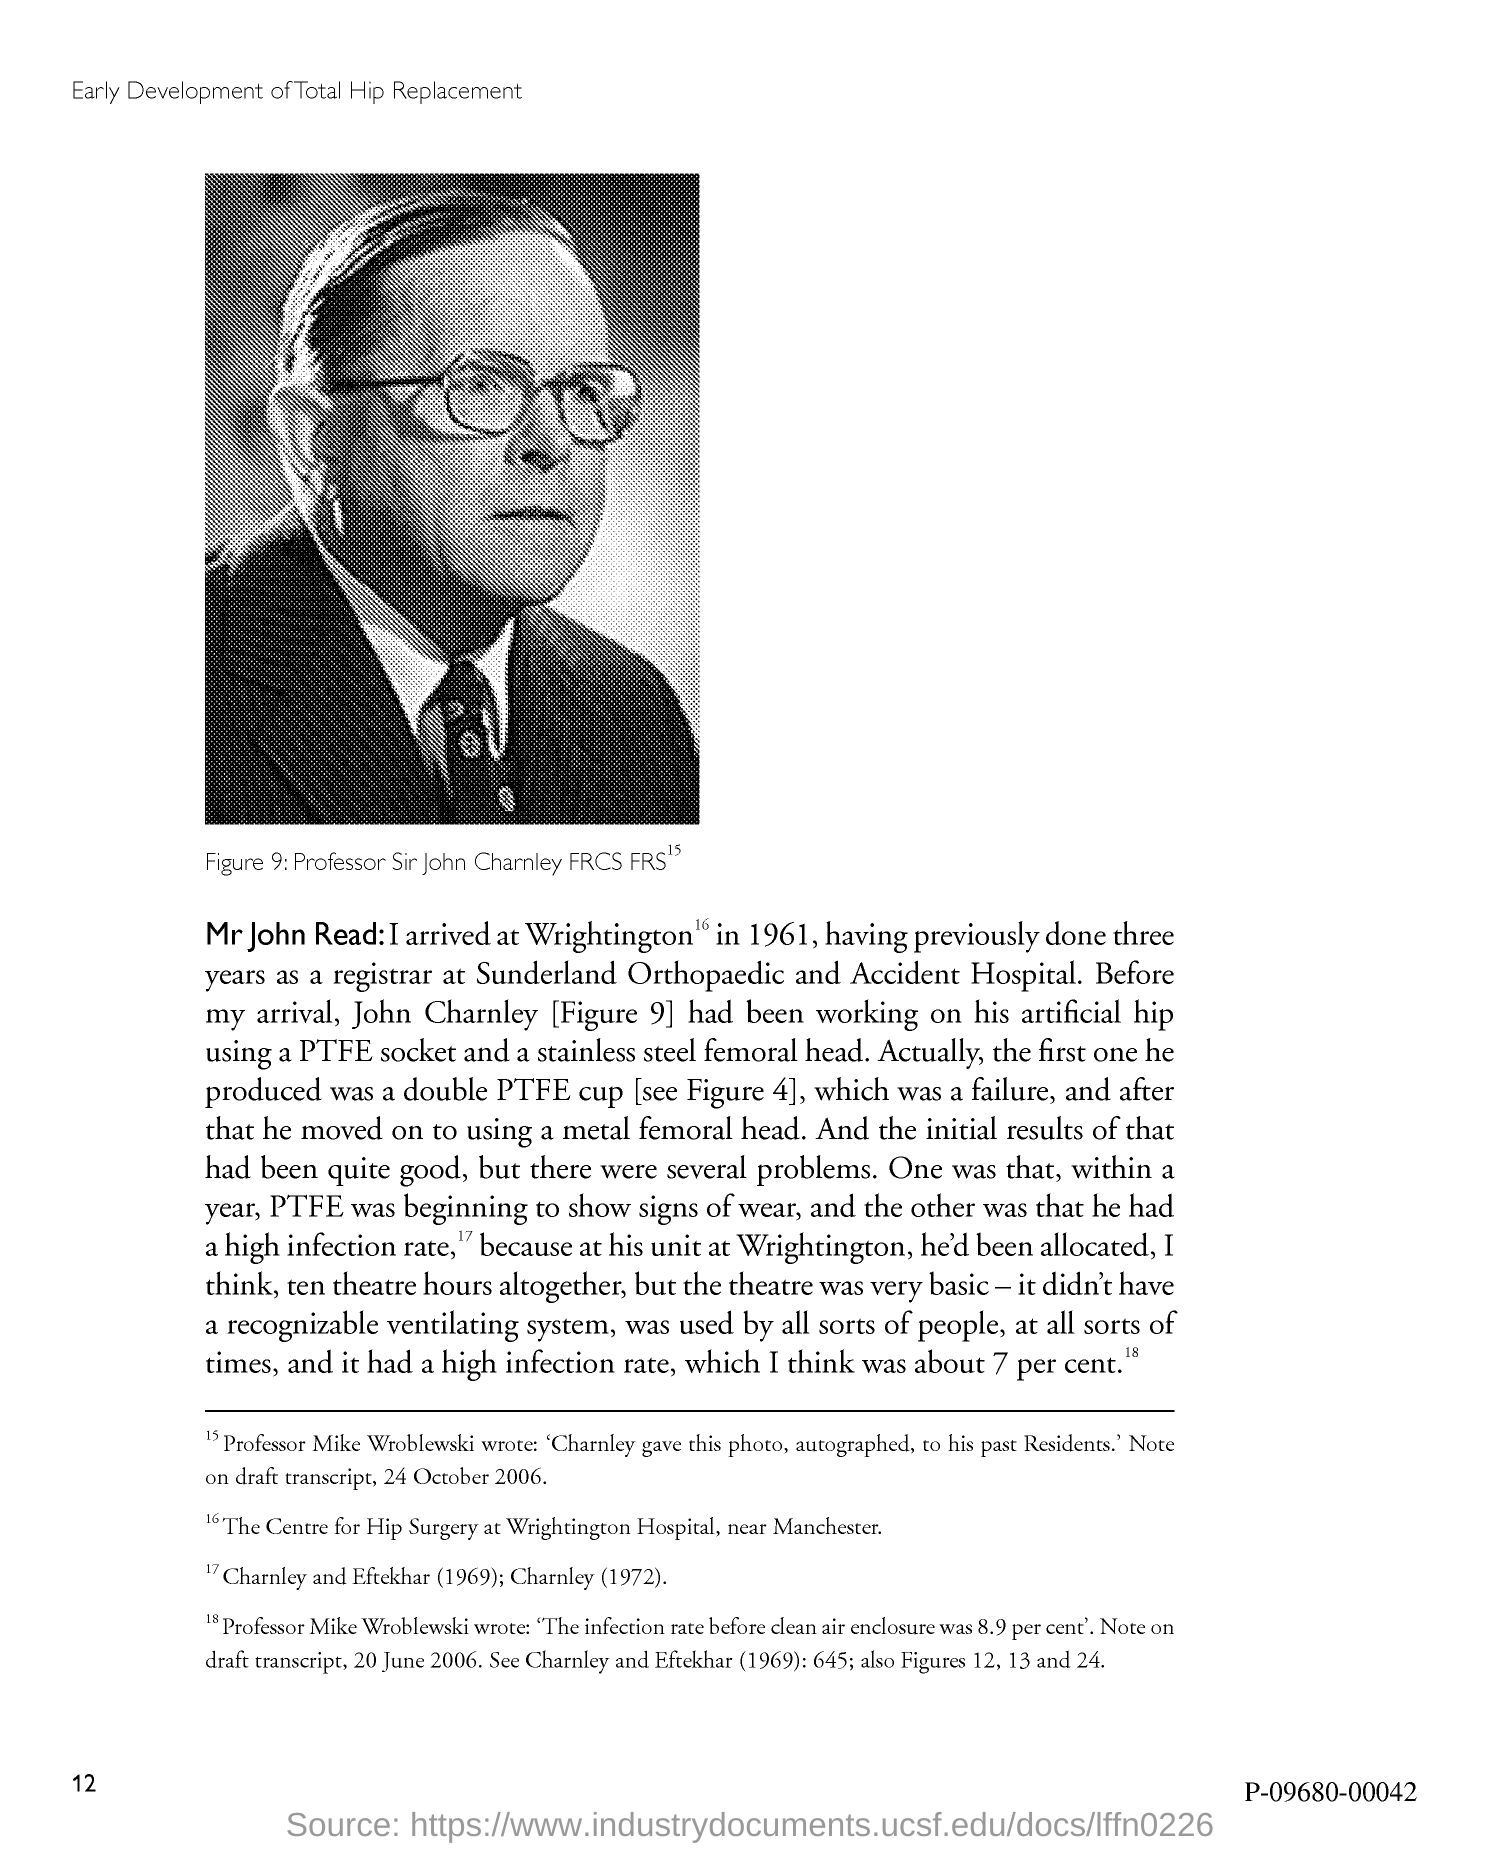Whose picture is shown in Figure 9?
Make the answer very short. Professor Sir John Charnley FRCS FRS. 